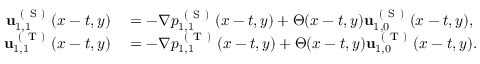Convert formula to latex. <formula><loc_0><loc_0><loc_500><loc_500>\begin{array} { r l } { u _ { 1 , 1 } ^ { ( S ) } ( x - t , y ) } & = - \nabla p _ { 1 , 1 } ^ { ( S ) } ( x - t , y ) + \Theta ( x - t , y ) u _ { 1 , 0 } ^ { ( S ) } ( x - t , y ) , } \\ { u _ { 1 , 1 } ^ { ( T ) } ( x - t , y ) } & = - \nabla p _ { 1 , 1 } ^ { ( T ) } ( x - t , y ) + \Theta ( x - t , y ) u _ { 1 , 0 } ^ { ( T ) } ( x - t , y ) . } \end{array}</formula> 